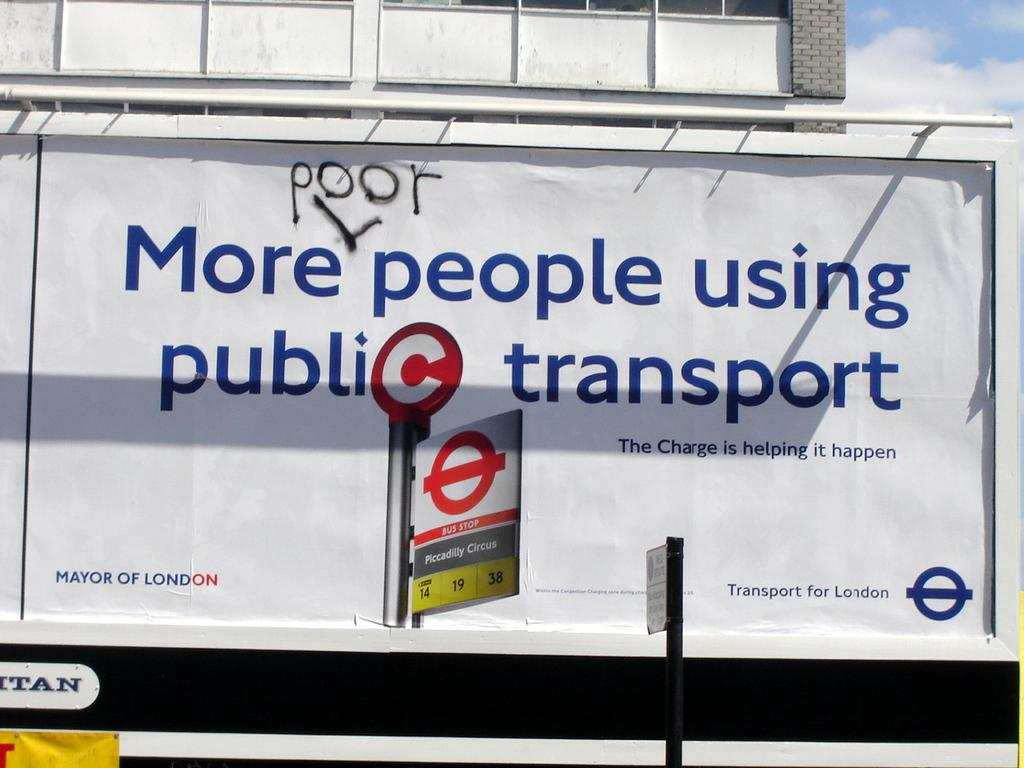<image>
Describe the image concisely. A white billboard on a road stating More people using public transport with the word poor with an arrow inserted between the words more and people. 